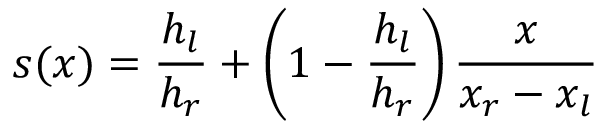<formula> <loc_0><loc_0><loc_500><loc_500>s ( x ) = \frac { h _ { l } } { h _ { r } } + \left ( 1 - \frac { h _ { l } } { h _ { r } } \right ) \frac { x } { x _ { r } - x _ { l } }</formula> 